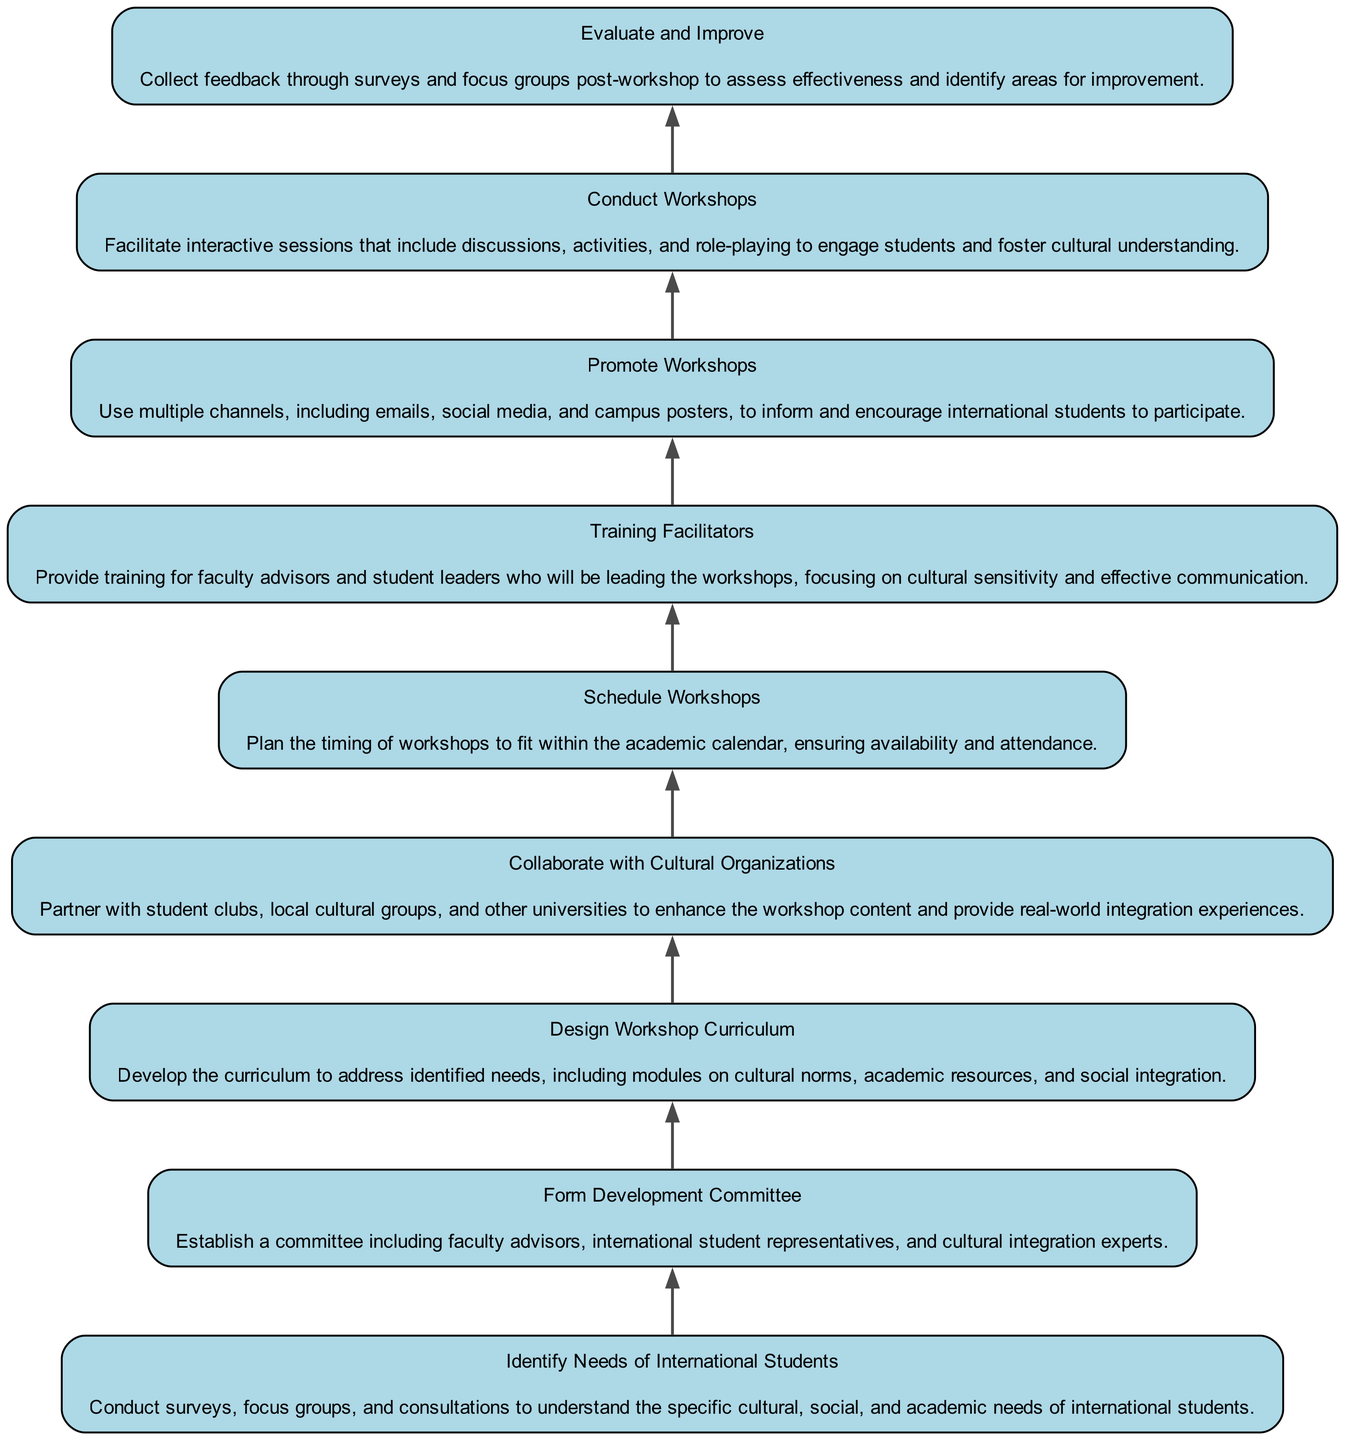What is the first step in the diagram? The first step is "Identify Needs of International Students". It is located at the bottom of the flow chart and represents the beginning of the development process.
Answer: Identify Needs of International Students How many total steps are there in the diagram? By counting each distinct step listed in the elements, we can see there are a total of 9 steps in the development process.
Answer: 9 What is the last step in the diagram? The last step is "Evaluate and Improve." It is the topmost node in the flow chart and signifies the conclusion of the process.
Answer: Evaluate and Improve Which step follows "Schedule Workshops"? The step that follows "Schedule Workshops" is "Training Facilitators." This can be determined by looking at the direct edge from "Schedule Workshops" to "Training Facilitators."
Answer: Training Facilitators What two steps are connected before the "Conduct Workshops" step? The two steps that connect before "Conduct Workshops" are "Promote Workshops" and "Training Facilitators." Both steps flow into the "Conduct Workshops" step, indicating they are prerequisites.
Answer: Promote Workshops, Training Facilitators Which steps involve collaboration with groups? The step "Collaborate with Cultural Organizations" explicitly states its focus on partnering with various cultural groups and organizations, making it the only step that involves this aspect directly.
Answer: Collaborate with Cultural Organizations What is the focus of the "Design Workshop Curriculum" step? The focus of "Design Workshop Curriculum" is to develop a curriculum that addresses the specific needs identified in the previous step, particularly regarding cultural norms and academic resources.
Answer: Develop the curriculum Which step emphasizes the importance of feedback? The step "Evaluate and Improve" emphasizes the importance of collecting feedback. This step is specifically aimed at assessing the effectiveness of the workshops and identifying areas for enhancement.
Answer: Evaluate and Improve What type of organizations does the "Collaborate with Cultural Organizations" step mention? This step mentions collaboration with "student clubs," "local cultural groups," and "other universities." These are specified as the types of organizations to be partnered with for enhanced workshop content.
Answer: Student clubs, local cultural groups, other universities 